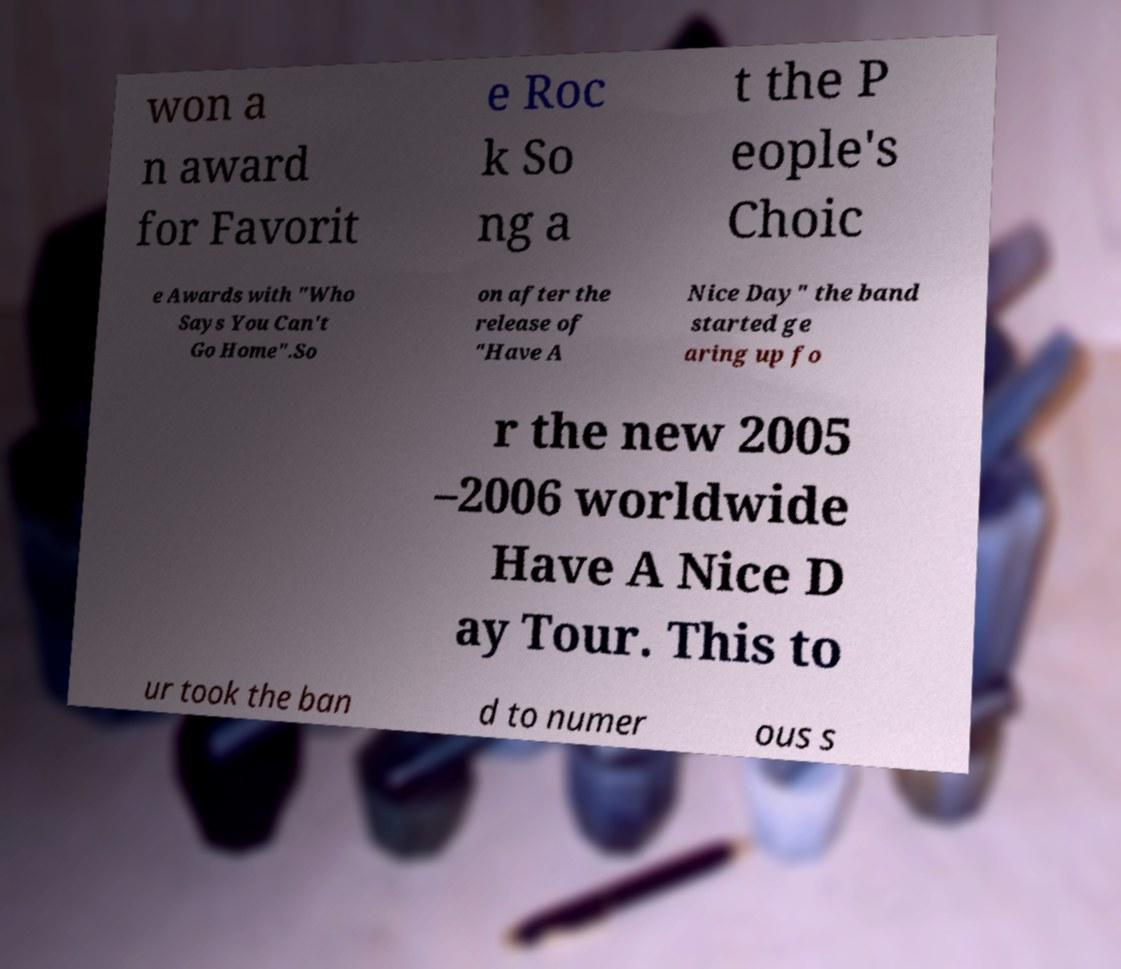What messages or text are displayed in this image? I need them in a readable, typed format. won a n award for Favorit e Roc k So ng a t the P eople's Choic e Awards with "Who Says You Can't Go Home".So on after the release of "Have A Nice Day" the band started ge aring up fo r the new 2005 –2006 worldwide Have A Nice D ay Tour. This to ur took the ban d to numer ous s 